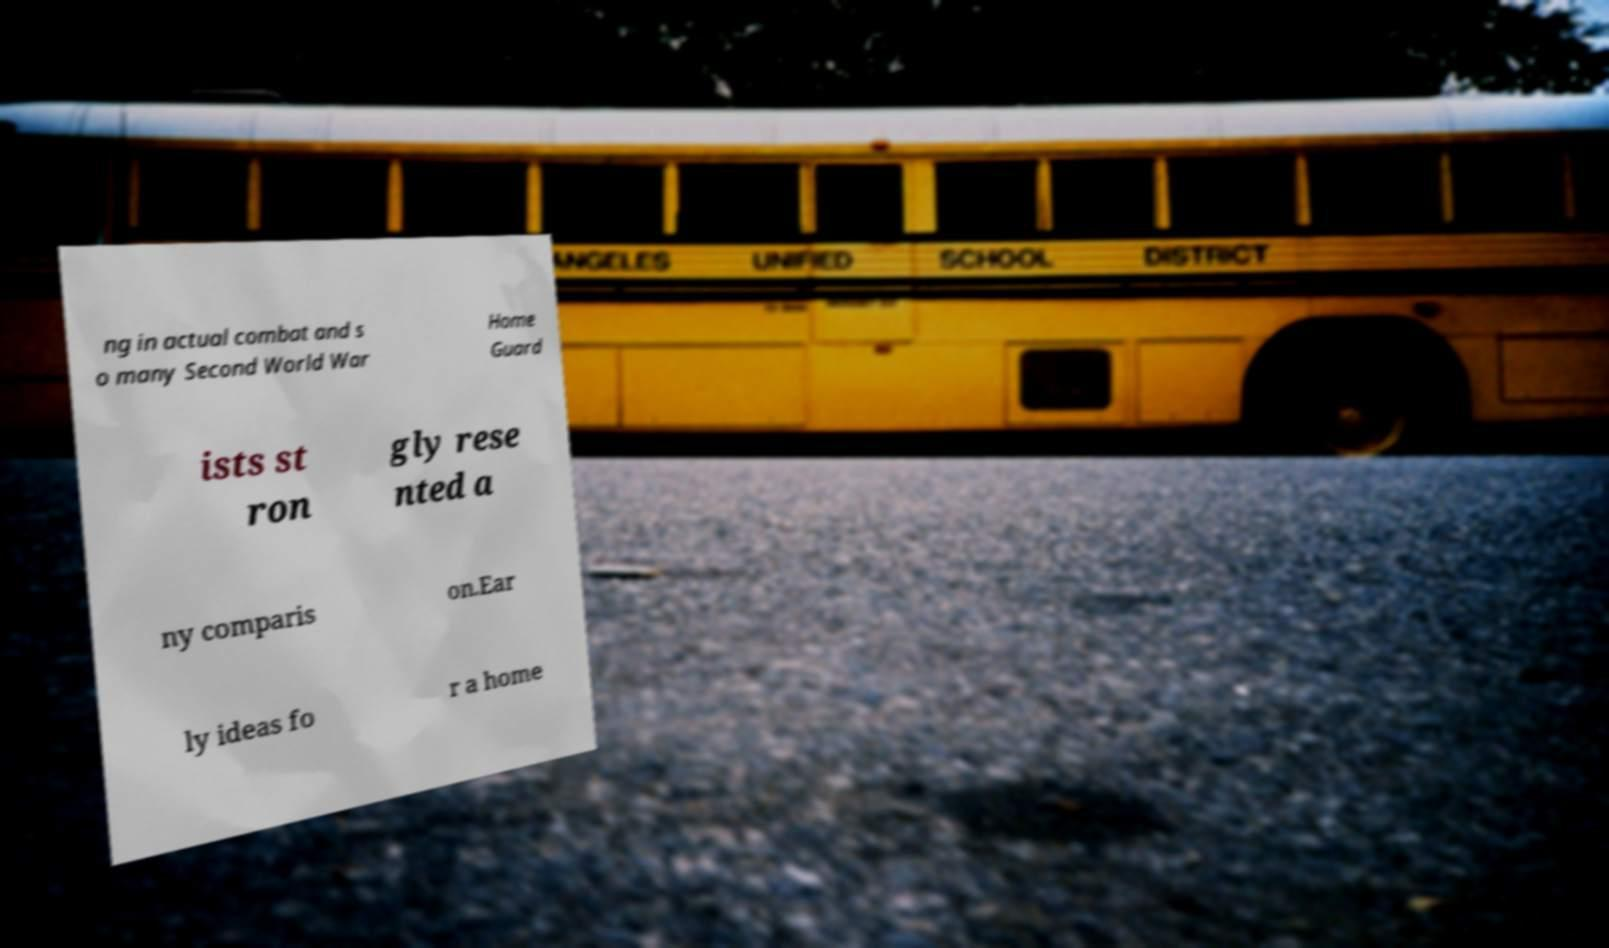What messages or text are displayed in this image? I need them in a readable, typed format. ng in actual combat and s o many Second World War Home Guard ists st ron gly rese nted a ny comparis on.Ear ly ideas fo r a home 